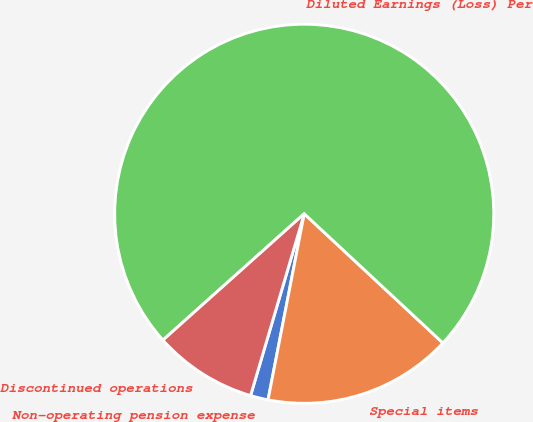<chart> <loc_0><loc_0><loc_500><loc_500><pie_chart><fcel>Non-operating pension expense<fcel>Special items<fcel>Diluted Earnings (Loss) Per<fcel>Discontinued operations<nl><fcel>1.51%<fcel>16.12%<fcel>73.55%<fcel>8.82%<nl></chart> 